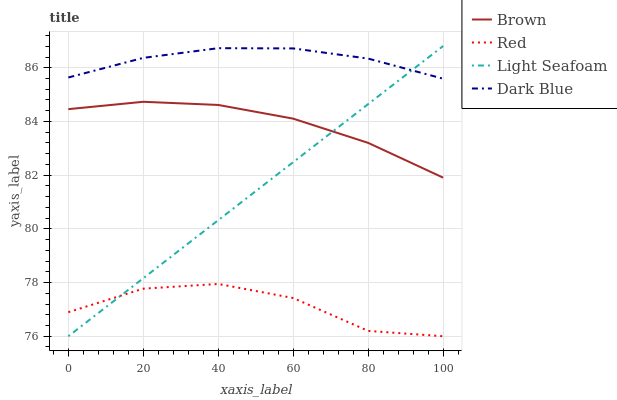Does Red have the minimum area under the curve?
Answer yes or no. Yes. Does Dark Blue have the maximum area under the curve?
Answer yes or no. Yes. Does Light Seafoam have the minimum area under the curve?
Answer yes or no. No. Does Light Seafoam have the maximum area under the curve?
Answer yes or no. No. Is Light Seafoam the smoothest?
Answer yes or no. Yes. Is Red the roughest?
Answer yes or no. Yes. Is Red the smoothest?
Answer yes or no. No. Is Light Seafoam the roughest?
Answer yes or no. No. Does Light Seafoam have the lowest value?
Answer yes or no. Yes. Does Dark Blue have the lowest value?
Answer yes or no. No. Does Light Seafoam have the highest value?
Answer yes or no. Yes. Does Red have the highest value?
Answer yes or no. No. Is Red less than Brown?
Answer yes or no. Yes. Is Dark Blue greater than Brown?
Answer yes or no. Yes. Does Light Seafoam intersect Brown?
Answer yes or no. Yes. Is Light Seafoam less than Brown?
Answer yes or no. No. Is Light Seafoam greater than Brown?
Answer yes or no. No. Does Red intersect Brown?
Answer yes or no. No. 